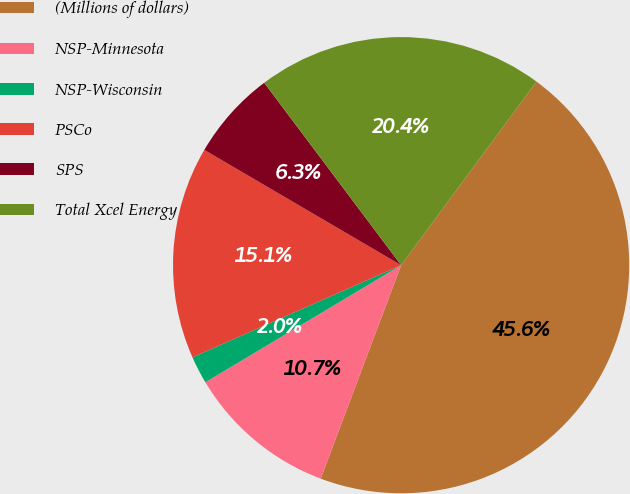Convert chart to OTSL. <chart><loc_0><loc_0><loc_500><loc_500><pie_chart><fcel>(Millions of dollars)<fcel>NSP-Minnesota<fcel>NSP-Wisconsin<fcel>PSCo<fcel>SPS<fcel>Total Xcel Energy<nl><fcel>45.62%<fcel>10.69%<fcel>1.96%<fcel>15.05%<fcel>6.32%<fcel>20.36%<nl></chart> 